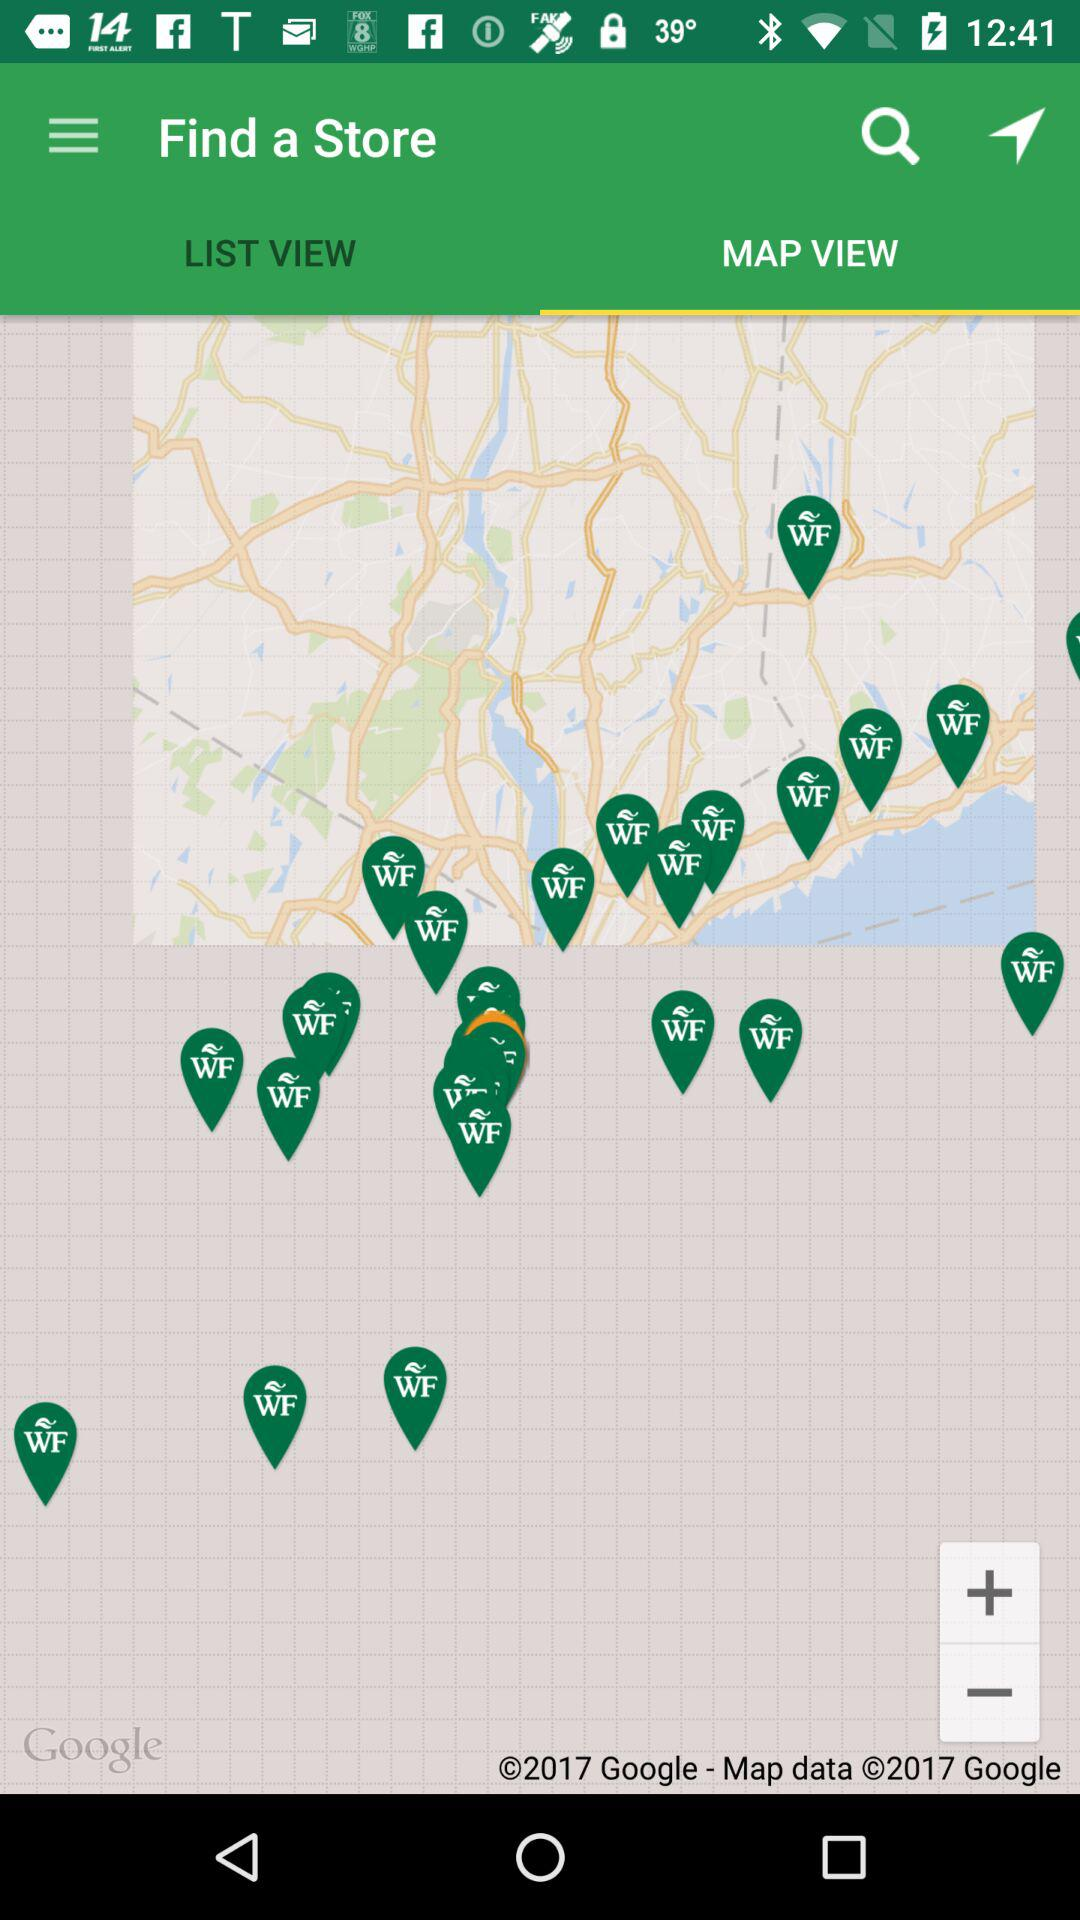Which tab is selected? The selected tab is "MAP VIEW". 